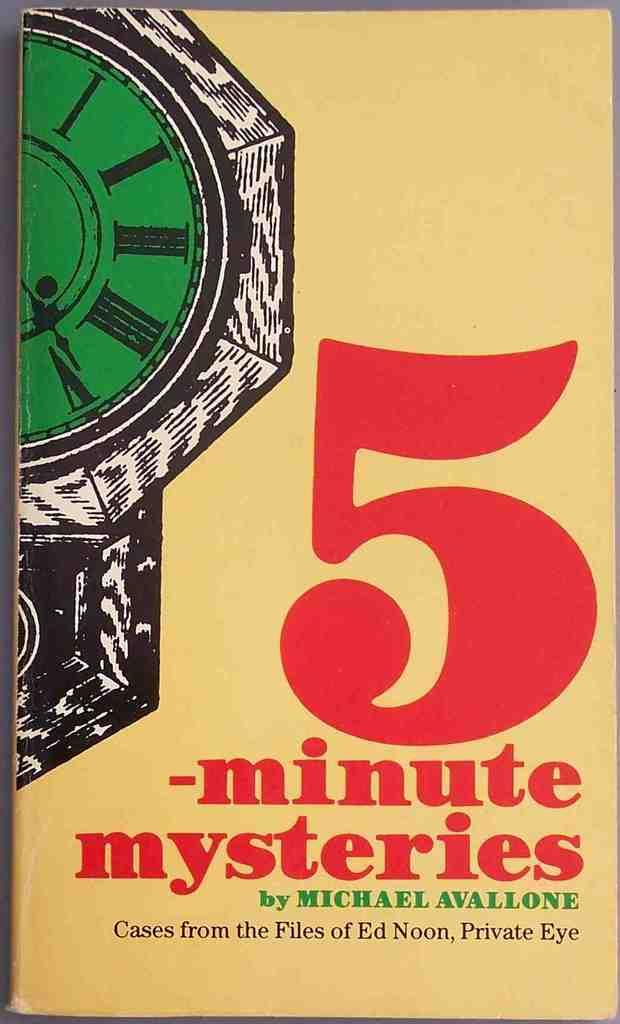Provide a one-sentence caption for the provided image. A book titled 5 -minute mysteries by Michael Avallone sits on a table. 